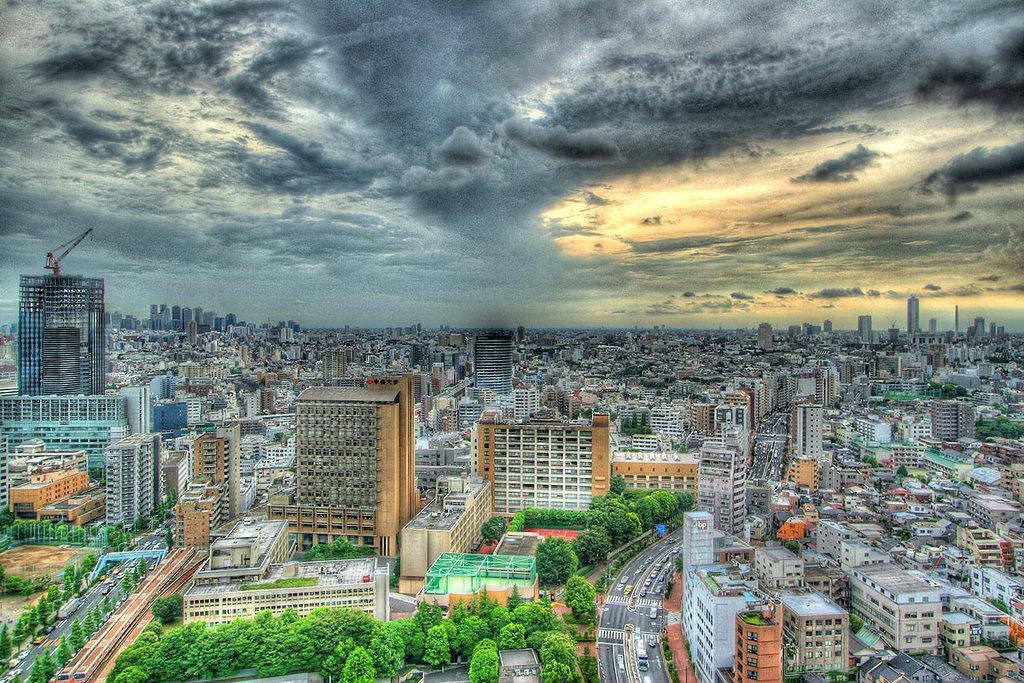Describe this image in one or two sentences. In this image, I can see the view of a city with the buildings, trees and vehicles on the roads. I can see the clouds in the sky. On the left side of the image, It looks like a tower crane, which is on the building. 